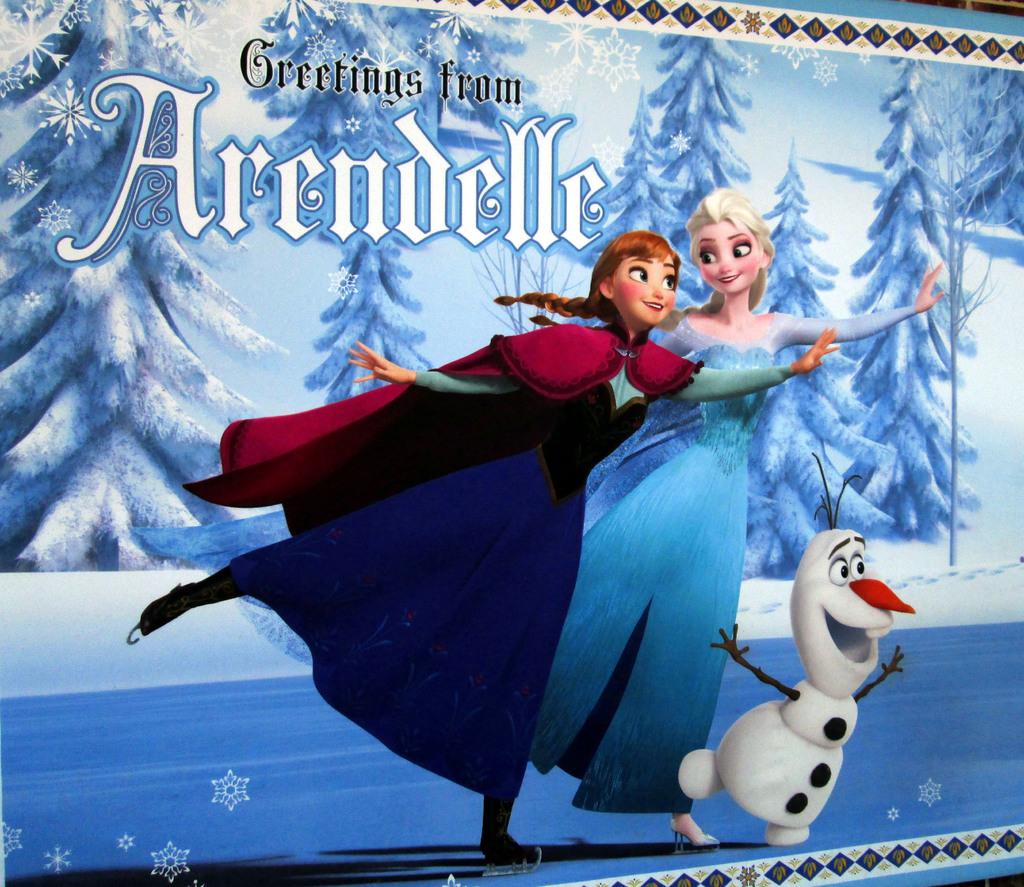Where is the card greeting us from?
Offer a very short reply. Arendelle. 